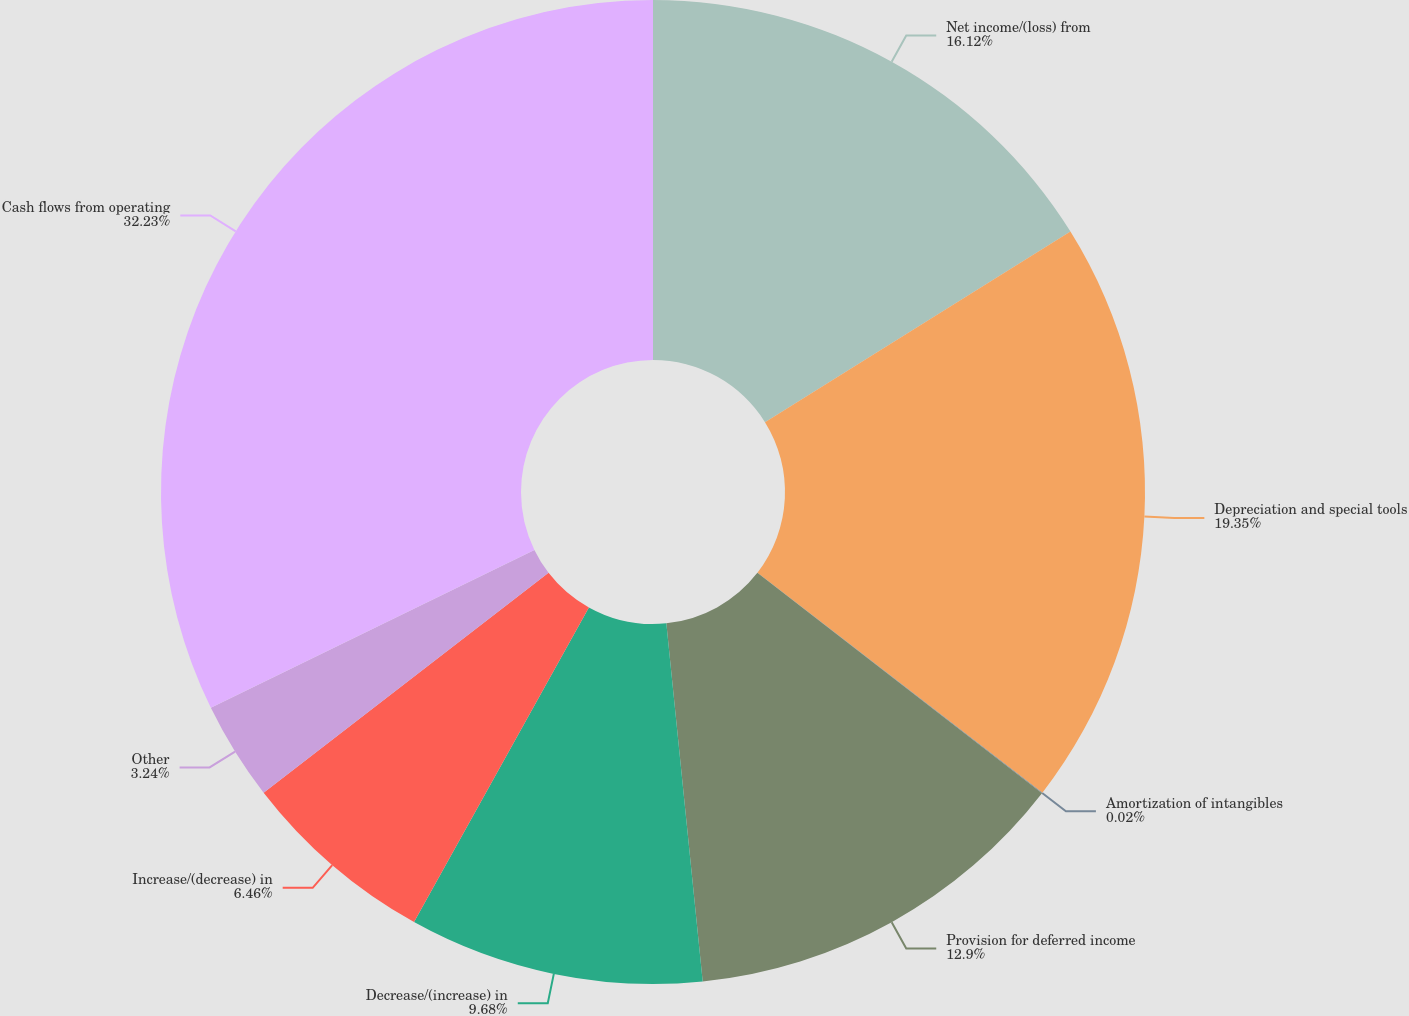<chart> <loc_0><loc_0><loc_500><loc_500><pie_chart><fcel>Net income/(loss) from<fcel>Depreciation and special tools<fcel>Amortization of intangibles<fcel>Provision for deferred income<fcel>Decrease/(increase) in<fcel>Increase/(decrease) in<fcel>Other<fcel>Cash flows from operating<nl><fcel>16.12%<fcel>19.34%<fcel>0.02%<fcel>12.9%<fcel>9.68%<fcel>6.46%<fcel>3.24%<fcel>32.22%<nl></chart> 